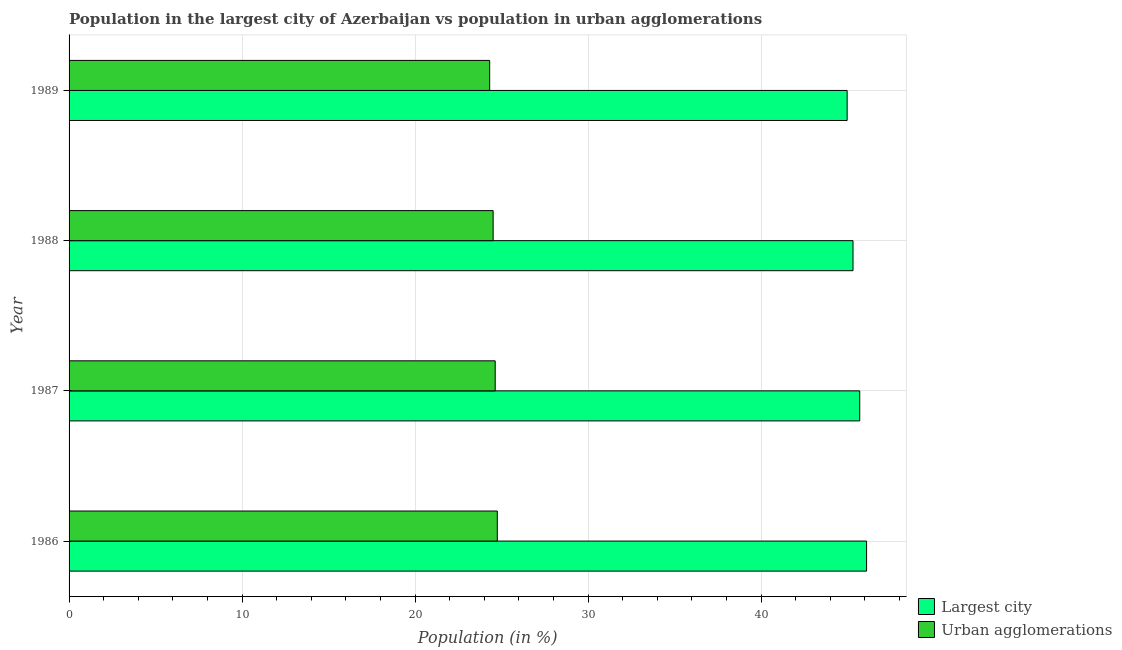How many different coloured bars are there?
Your answer should be very brief. 2. How many groups of bars are there?
Provide a succinct answer. 4. How many bars are there on the 3rd tick from the bottom?
Provide a succinct answer. 2. What is the population in urban agglomerations in 1989?
Give a very brief answer. 24.31. Across all years, what is the maximum population in the largest city?
Provide a short and direct response. 46.1. Across all years, what is the minimum population in urban agglomerations?
Provide a short and direct response. 24.31. What is the total population in urban agglomerations in the graph?
Provide a short and direct response. 98.21. What is the difference between the population in urban agglomerations in 1988 and that in 1989?
Offer a very short reply. 0.2. What is the difference between the population in the largest city in 1989 and the population in urban agglomerations in 1986?
Offer a terse response. 20.22. What is the average population in the largest city per year?
Offer a terse response. 45.52. In the year 1987, what is the difference between the population in the largest city and population in urban agglomerations?
Offer a very short reply. 21.07. In how many years, is the population in urban agglomerations greater than 40 %?
Your answer should be compact. 0. Is the population in the largest city in 1986 less than that in 1988?
Ensure brevity in your answer.  No. What is the difference between the highest and the second highest population in urban agglomerations?
Make the answer very short. 0.12. What is the difference between the highest and the lowest population in the largest city?
Your answer should be compact. 1.12. Is the sum of the population in urban agglomerations in 1988 and 1989 greater than the maximum population in the largest city across all years?
Your answer should be compact. Yes. What does the 1st bar from the top in 1987 represents?
Your answer should be very brief. Urban agglomerations. What does the 1st bar from the bottom in 1989 represents?
Give a very brief answer. Largest city. Are all the bars in the graph horizontal?
Make the answer very short. Yes. What is the difference between two consecutive major ticks on the X-axis?
Keep it short and to the point. 10. Are the values on the major ticks of X-axis written in scientific E-notation?
Keep it short and to the point. No. Does the graph contain grids?
Ensure brevity in your answer.  Yes. Where does the legend appear in the graph?
Your response must be concise. Bottom right. How are the legend labels stacked?
Your answer should be very brief. Vertical. What is the title of the graph?
Offer a very short reply. Population in the largest city of Azerbaijan vs population in urban agglomerations. Does "Urban" appear as one of the legend labels in the graph?
Provide a succinct answer. No. What is the label or title of the X-axis?
Your answer should be compact. Population (in %). What is the label or title of the Y-axis?
Offer a very short reply. Year. What is the Population (in %) of Largest city in 1986?
Ensure brevity in your answer.  46.1. What is the Population (in %) of Urban agglomerations in 1986?
Offer a terse response. 24.75. What is the Population (in %) in Largest city in 1987?
Ensure brevity in your answer.  45.7. What is the Population (in %) of Urban agglomerations in 1987?
Make the answer very short. 24.63. What is the Population (in %) of Largest city in 1988?
Make the answer very short. 45.31. What is the Population (in %) of Urban agglomerations in 1988?
Offer a very short reply. 24.51. What is the Population (in %) of Largest city in 1989?
Provide a succinct answer. 44.97. What is the Population (in %) in Urban agglomerations in 1989?
Give a very brief answer. 24.31. Across all years, what is the maximum Population (in %) of Largest city?
Make the answer very short. 46.1. Across all years, what is the maximum Population (in %) of Urban agglomerations?
Ensure brevity in your answer.  24.75. Across all years, what is the minimum Population (in %) in Largest city?
Provide a succinct answer. 44.97. Across all years, what is the minimum Population (in %) in Urban agglomerations?
Provide a short and direct response. 24.31. What is the total Population (in %) in Largest city in the graph?
Your answer should be compact. 182.09. What is the total Population (in %) of Urban agglomerations in the graph?
Provide a succinct answer. 98.21. What is the difference between the Population (in %) in Largest city in 1986 and that in 1987?
Make the answer very short. 0.39. What is the difference between the Population (in %) of Urban agglomerations in 1986 and that in 1987?
Your response must be concise. 0.12. What is the difference between the Population (in %) in Largest city in 1986 and that in 1988?
Offer a very short reply. 0.78. What is the difference between the Population (in %) of Urban agglomerations in 1986 and that in 1988?
Your answer should be very brief. 0.24. What is the difference between the Population (in %) of Largest city in 1986 and that in 1989?
Provide a succinct answer. 1.12. What is the difference between the Population (in %) in Urban agglomerations in 1986 and that in 1989?
Make the answer very short. 0.44. What is the difference between the Population (in %) in Largest city in 1987 and that in 1988?
Your answer should be very brief. 0.39. What is the difference between the Population (in %) of Urban agglomerations in 1987 and that in 1988?
Ensure brevity in your answer.  0.12. What is the difference between the Population (in %) in Largest city in 1987 and that in 1989?
Provide a short and direct response. 0.73. What is the difference between the Population (in %) in Urban agglomerations in 1987 and that in 1989?
Ensure brevity in your answer.  0.32. What is the difference between the Population (in %) of Largest city in 1988 and that in 1989?
Your answer should be very brief. 0.34. What is the difference between the Population (in %) in Urban agglomerations in 1988 and that in 1989?
Your answer should be compact. 0.2. What is the difference between the Population (in %) of Largest city in 1986 and the Population (in %) of Urban agglomerations in 1987?
Offer a terse response. 21.47. What is the difference between the Population (in %) in Largest city in 1986 and the Population (in %) in Urban agglomerations in 1988?
Give a very brief answer. 21.58. What is the difference between the Population (in %) in Largest city in 1986 and the Population (in %) in Urban agglomerations in 1989?
Give a very brief answer. 21.79. What is the difference between the Population (in %) of Largest city in 1987 and the Population (in %) of Urban agglomerations in 1988?
Make the answer very short. 21.19. What is the difference between the Population (in %) of Largest city in 1987 and the Population (in %) of Urban agglomerations in 1989?
Make the answer very short. 21.39. What is the difference between the Population (in %) in Largest city in 1988 and the Population (in %) in Urban agglomerations in 1989?
Your answer should be compact. 21. What is the average Population (in %) of Largest city per year?
Provide a succinct answer. 45.52. What is the average Population (in %) in Urban agglomerations per year?
Provide a succinct answer. 24.55. In the year 1986, what is the difference between the Population (in %) in Largest city and Population (in %) in Urban agglomerations?
Ensure brevity in your answer.  21.34. In the year 1987, what is the difference between the Population (in %) of Largest city and Population (in %) of Urban agglomerations?
Keep it short and to the point. 21.07. In the year 1988, what is the difference between the Population (in %) of Largest city and Population (in %) of Urban agglomerations?
Your answer should be very brief. 20.8. In the year 1989, what is the difference between the Population (in %) of Largest city and Population (in %) of Urban agglomerations?
Offer a terse response. 20.66. What is the ratio of the Population (in %) in Largest city in 1986 to that in 1987?
Keep it short and to the point. 1.01. What is the ratio of the Population (in %) of Urban agglomerations in 1986 to that in 1987?
Keep it short and to the point. 1. What is the ratio of the Population (in %) in Largest city in 1986 to that in 1988?
Ensure brevity in your answer.  1.02. What is the ratio of the Population (in %) in Urban agglomerations in 1986 to that in 1988?
Your answer should be very brief. 1.01. What is the ratio of the Population (in %) of Largest city in 1986 to that in 1989?
Ensure brevity in your answer.  1.02. What is the ratio of the Population (in %) in Urban agglomerations in 1986 to that in 1989?
Your answer should be very brief. 1.02. What is the ratio of the Population (in %) of Largest city in 1987 to that in 1988?
Your response must be concise. 1.01. What is the ratio of the Population (in %) in Largest city in 1987 to that in 1989?
Your answer should be compact. 1.02. What is the ratio of the Population (in %) of Urban agglomerations in 1987 to that in 1989?
Offer a very short reply. 1.01. What is the ratio of the Population (in %) in Largest city in 1988 to that in 1989?
Provide a succinct answer. 1.01. What is the ratio of the Population (in %) in Urban agglomerations in 1988 to that in 1989?
Provide a succinct answer. 1.01. What is the difference between the highest and the second highest Population (in %) in Largest city?
Provide a succinct answer. 0.39. What is the difference between the highest and the second highest Population (in %) of Urban agglomerations?
Offer a very short reply. 0.12. What is the difference between the highest and the lowest Population (in %) of Largest city?
Your response must be concise. 1.12. What is the difference between the highest and the lowest Population (in %) in Urban agglomerations?
Ensure brevity in your answer.  0.44. 